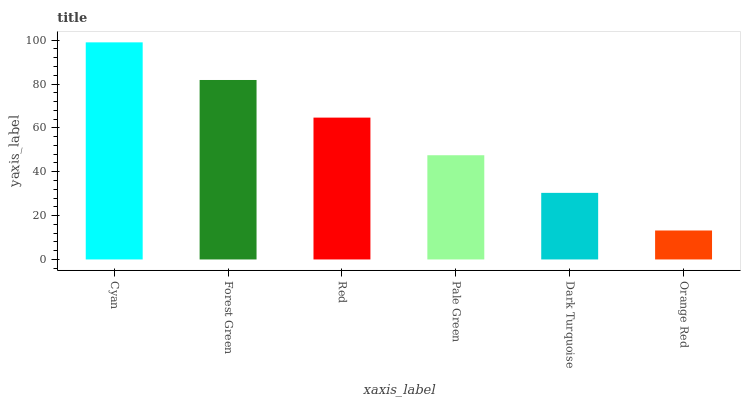Is Orange Red the minimum?
Answer yes or no. Yes. Is Cyan the maximum?
Answer yes or no. Yes. Is Forest Green the minimum?
Answer yes or no. No. Is Forest Green the maximum?
Answer yes or no. No. Is Cyan greater than Forest Green?
Answer yes or no. Yes. Is Forest Green less than Cyan?
Answer yes or no. Yes. Is Forest Green greater than Cyan?
Answer yes or no. No. Is Cyan less than Forest Green?
Answer yes or no. No. Is Red the high median?
Answer yes or no. Yes. Is Pale Green the low median?
Answer yes or no. Yes. Is Forest Green the high median?
Answer yes or no. No. Is Dark Turquoise the low median?
Answer yes or no. No. 